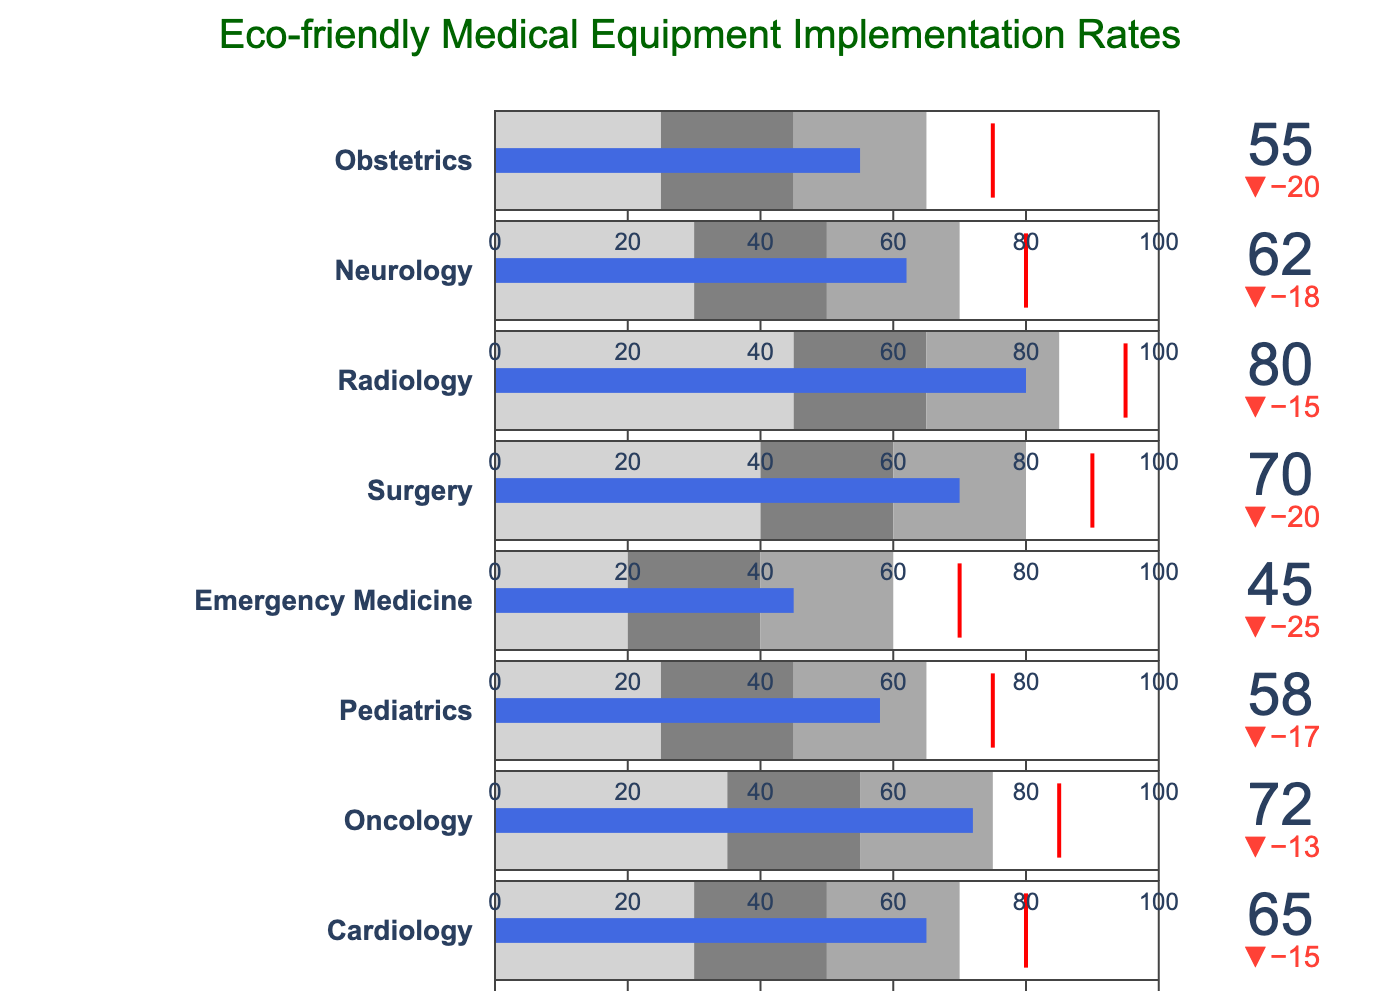What is the implementation rate of eco-friendly medical equipment for the Radiology specialty? To find the implementation rate for Radiology, locate the "Radiology" bar and read the "Actual" value.
Answer: 80 What is the target implementation rate for the Pediatrics specialty? To find the target rate for Pediatrics, locate the "Pediatrics" bar and read the "Target" value.
Answer: 75 Which specialty has the highest actual implementation rate of eco-friendly medical equipment? To determine the specialty with the highest implementation rate, compare the "Actual" values for all specialties and find the highest one.
Answer: Radiology How much lower is the actual implementation rate compared to the target for Neurology? Subtract the actual rate from the target rate for Neurology. (80 - 62 = 18)
Answer: 18 Which specialties have an actual implementation rate that falls between their "Poor" and "Satisfactory" thresholds? Check each specialty's "Actual" value and see if it is between their "Poor" and "Satisfactory" thresholds. For Emergency Medicine: 45 is between 20 and 40. For Oncology: 72 is between 55 and 75.
Answer: Emergency Medicine, Oncology What is the color of the zone representing "Satisfactory" performance for Obstetrics? Identify the color used between the "Poor" and "Good" thresholds for Obstetrics; the middle color is "gray".
Answer: Gray How many specialties have their actual implementation rate below 60? Count the number of specialties where the "Actual" value is less than 60. (Emergency Medicine, Pediatrics, and Obstetrics have values below 60.)
Answer: 3 Is the Oncology specialty meeting its target implementation rate? Compare Oncology's "Actual" value (72) to its "Target" (85). Since 72 is less than 85, it does not meet the target.
Answer: No 